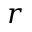Convert formula to latex. <formula><loc_0><loc_0><loc_500><loc_500>r</formula> 